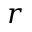Convert formula to latex. <formula><loc_0><loc_0><loc_500><loc_500>r</formula> 